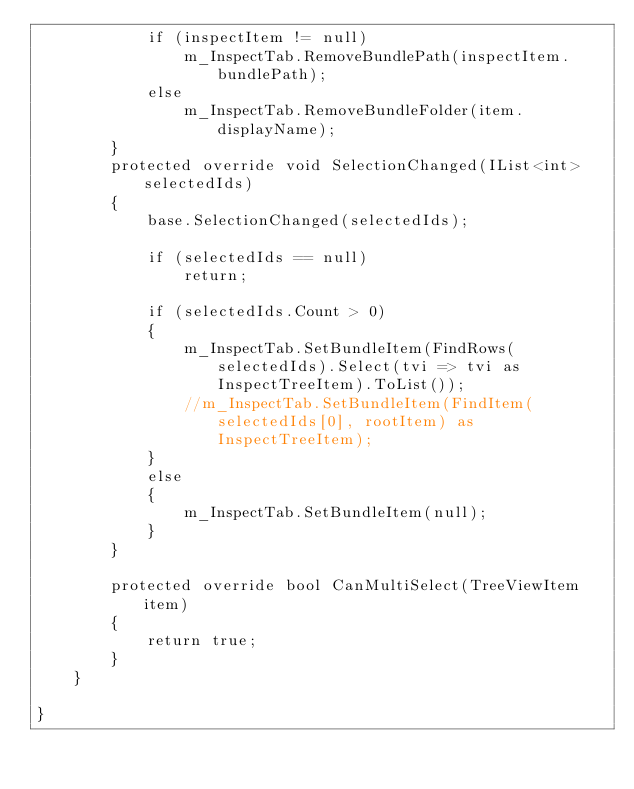<code> <loc_0><loc_0><loc_500><loc_500><_C#_>            if (inspectItem != null)
                m_InspectTab.RemoveBundlePath(inspectItem.bundlePath);
            else
                m_InspectTab.RemoveBundleFolder(item.displayName);
        }
        protected override void SelectionChanged(IList<int> selectedIds)
		{
			base.SelectionChanged(selectedIds);

            if (selectedIds == null)
                return;

			if (selectedIds.Count > 0)
			{
                m_InspectTab.SetBundleItem(FindRows(selectedIds).Select(tvi => tvi as InspectTreeItem).ToList());
				//m_InspectTab.SetBundleItem(FindItem(selectedIds[0], rootItem) as InspectTreeItem);
			}
			else
            {
				m_InspectTab.SetBundleItem(null);
            }
		}

		protected override bool CanMultiSelect(TreeViewItem item)
		{
			return true;
		}
	}

}
</code> 